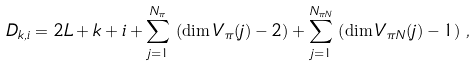Convert formula to latex. <formula><loc_0><loc_0><loc_500><loc_500>D _ { k , i } = 2 L + k + i + \sum _ { j = 1 } ^ { N _ { \pi } } \, \left ( \dim { V _ { \pi } } ( j ) - 2 \right ) + \sum _ { j = 1 } ^ { N _ { \pi N } } \, \left ( \dim V _ { \pi N } ( j ) - 1 \right ) \, ,</formula> 